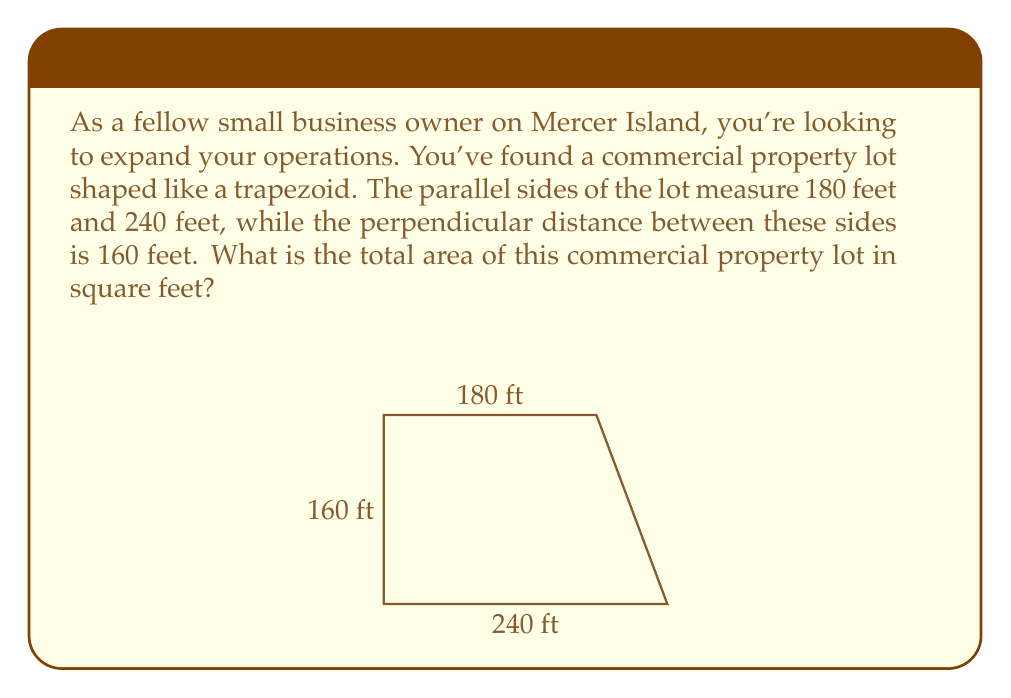Teach me how to tackle this problem. To calculate the area of a trapezoid, we use the formula:

$$ A = \frac{1}{2}(b_1 + b_2)h $$

Where:
$A$ = Area
$b_1$ and $b_2$ = Lengths of the parallel sides
$h$ = Height (perpendicular distance between the parallel sides)

Given:
$b_1 = 180$ feet
$b_2 = 240$ feet
$h = 160$ feet

Let's substitute these values into the formula:

$$ A = \frac{1}{2}(180 + 240) \times 160 $$

First, add the parallel sides:
$$ A = \frac{1}{2}(420) \times 160 $$

Now multiply:
$$ A = 210 \times 160 $$

$$ A = 33,600 $$

Therefore, the area of the commercial property lot is 33,600 square feet.
Answer: 33,600 square feet 